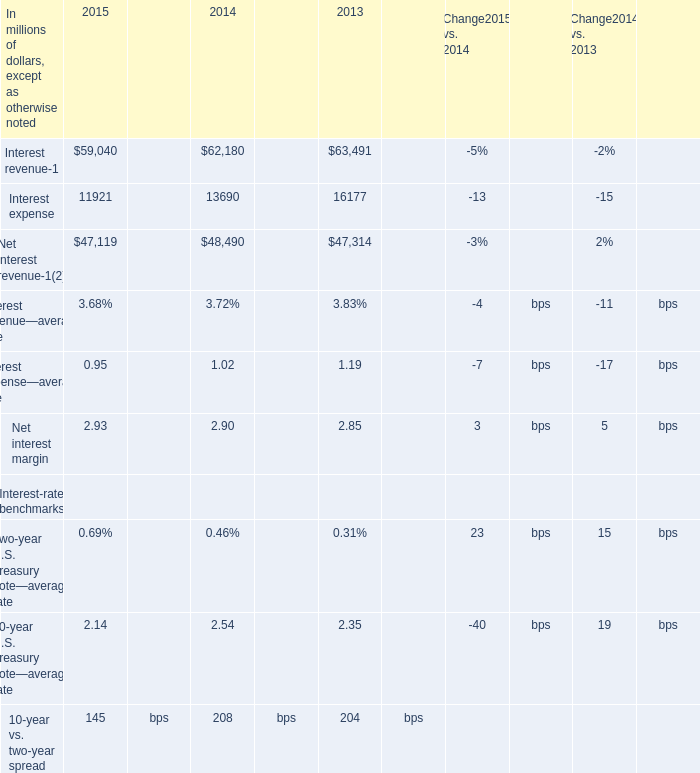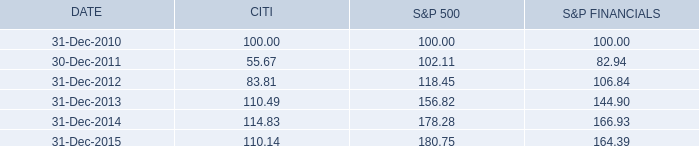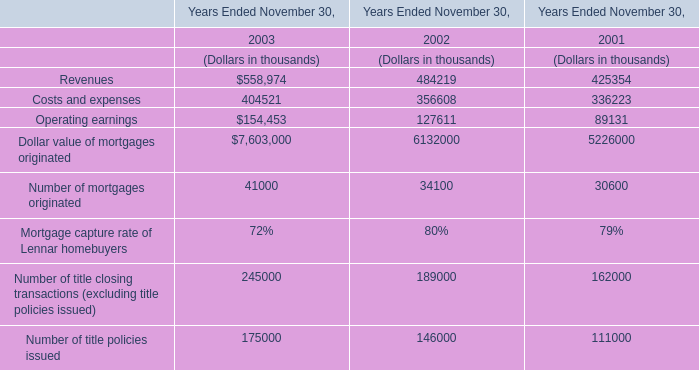What was the total amount of Interest expense excluding those Net interest margin greater than 2.9 in 2013? (in million) 
Answer: 16177. 